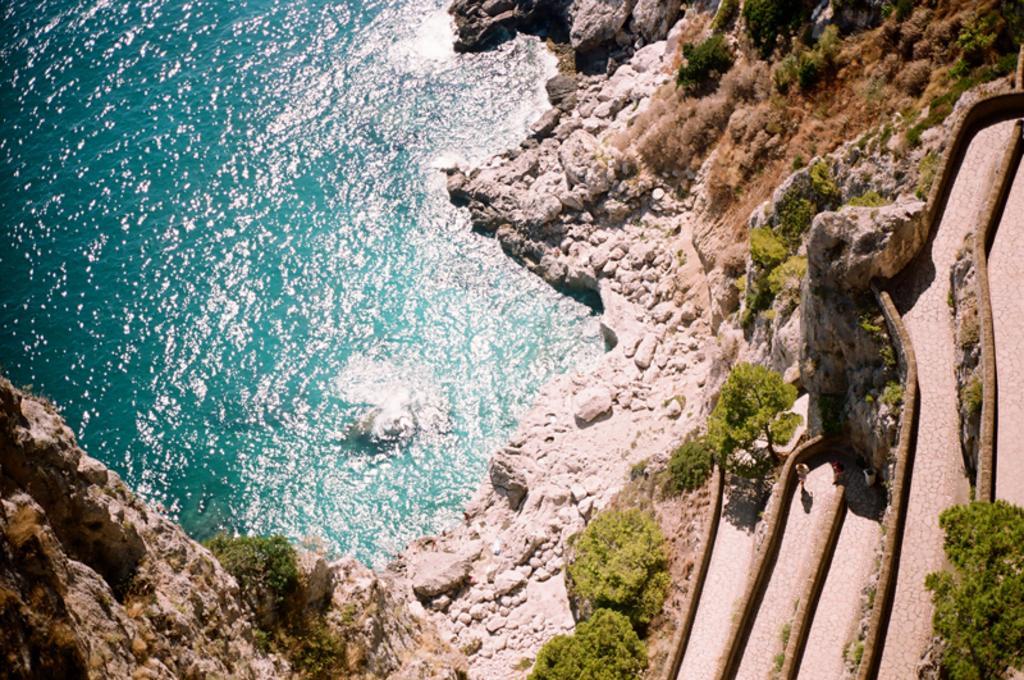Please provide a concise description of this image. In the image we see water, which is surrounded by land and there are rocks on it and there is a bit of greenery and there is a path too. 